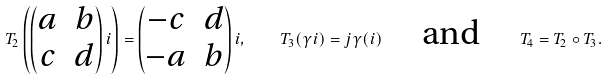<formula> <loc_0><loc_0><loc_500><loc_500>T _ { 2 } \left ( \begin{pmatrix} a & b \\ c & d \end{pmatrix} i \right ) = \begin{pmatrix} - c & d \\ - a & b \end{pmatrix} i , \quad T _ { 3 } ( \gamma i ) = j \gamma ( i ) \quad \ \text {and} \ \quad T _ { 4 } = T _ { 2 } \circ T _ { 3 } .</formula> 